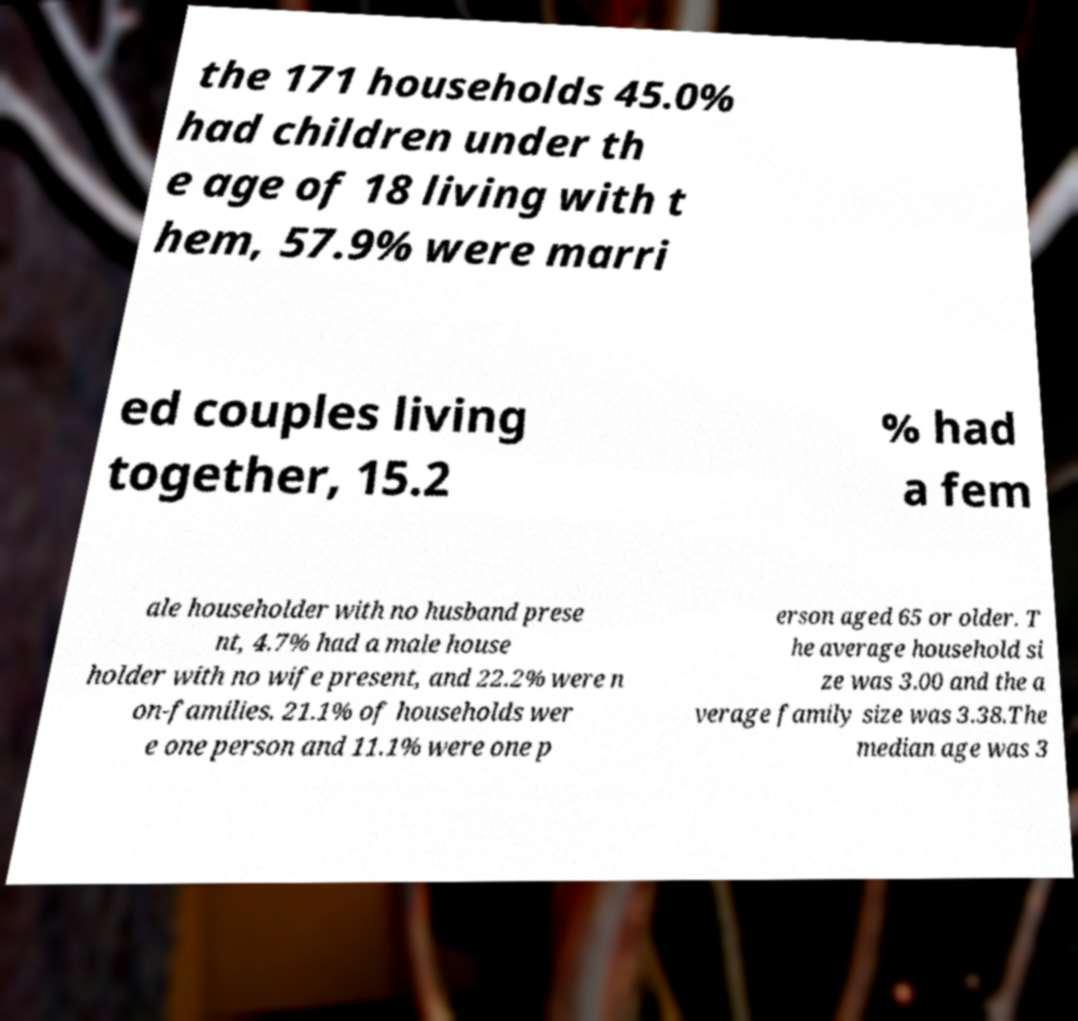I need the written content from this picture converted into text. Can you do that? the 171 households 45.0% had children under th e age of 18 living with t hem, 57.9% were marri ed couples living together, 15.2 % had a fem ale householder with no husband prese nt, 4.7% had a male house holder with no wife present, and 22.2% were n on-families. 21.1% of households wer e one person and 11.1% were one p erson aged 65 or older. T he average household si ze was 3.00 and the a verage family size was 3.38.The median age was 3 